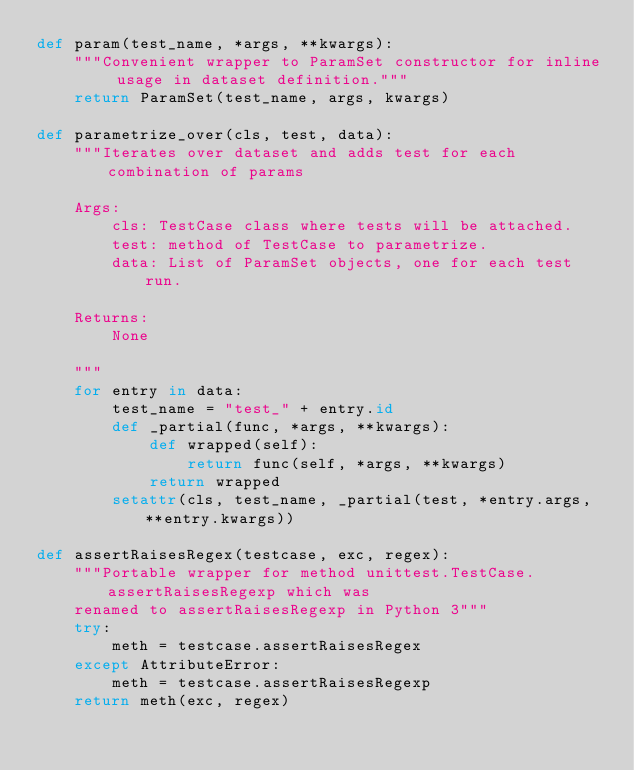<code> <loc_0><loc_0><loc_500><loc_500><_Python_>def param(test_name, *args, **kwargs):
    """Convenient wrapper to ParamSet constructor for inline usage in dataset definition."""
    return ParamSet(test_name, args, kwargs)

def parametrize_over(cls, test, data):
    """Iterates over dataset and adds test for each combination of params

    Args:
        cls: TestCase class where tests will be attached.
        test: method of TestCase to parametrize.
        data: List of ParamSet objects, one for each test run.

    Returns:
        None

    """
    for entry in data:
        test_name = "test_" + entry.id
        def _partial(func, *args, **kwargs):
            def wrapped(self):
                return func(self, *args, **kwargs)
            return wrapped
        setattr(cls, test_name, _partial(test, *entry.args, **entry.kwargs))

def assertRaisesRegex(testcase, exc, regex):
    """Portable wrapper for method unittest.TestCase.assertRaisesRegexp which was
    renamed to assertRaisesRegexp in Python 3"""
    try:
        meth = testcase.assertRaisesRegex
    except AttributeError:
        meth = testcase.assertRaisesRegexp
    return meth(exc, regex)
</code> 